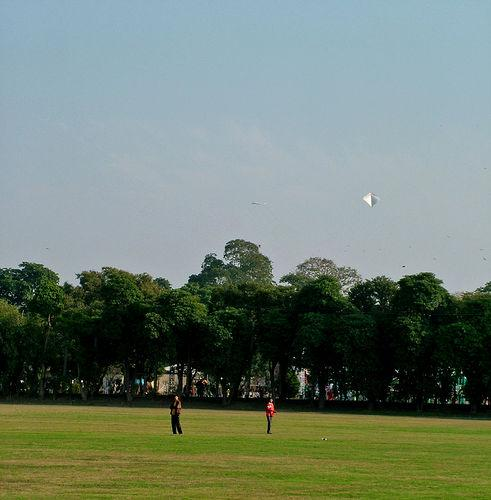What is the best shape for a kite?

Choices:
A) square
B) triangular
C) rectangle
D) diamond diamond 